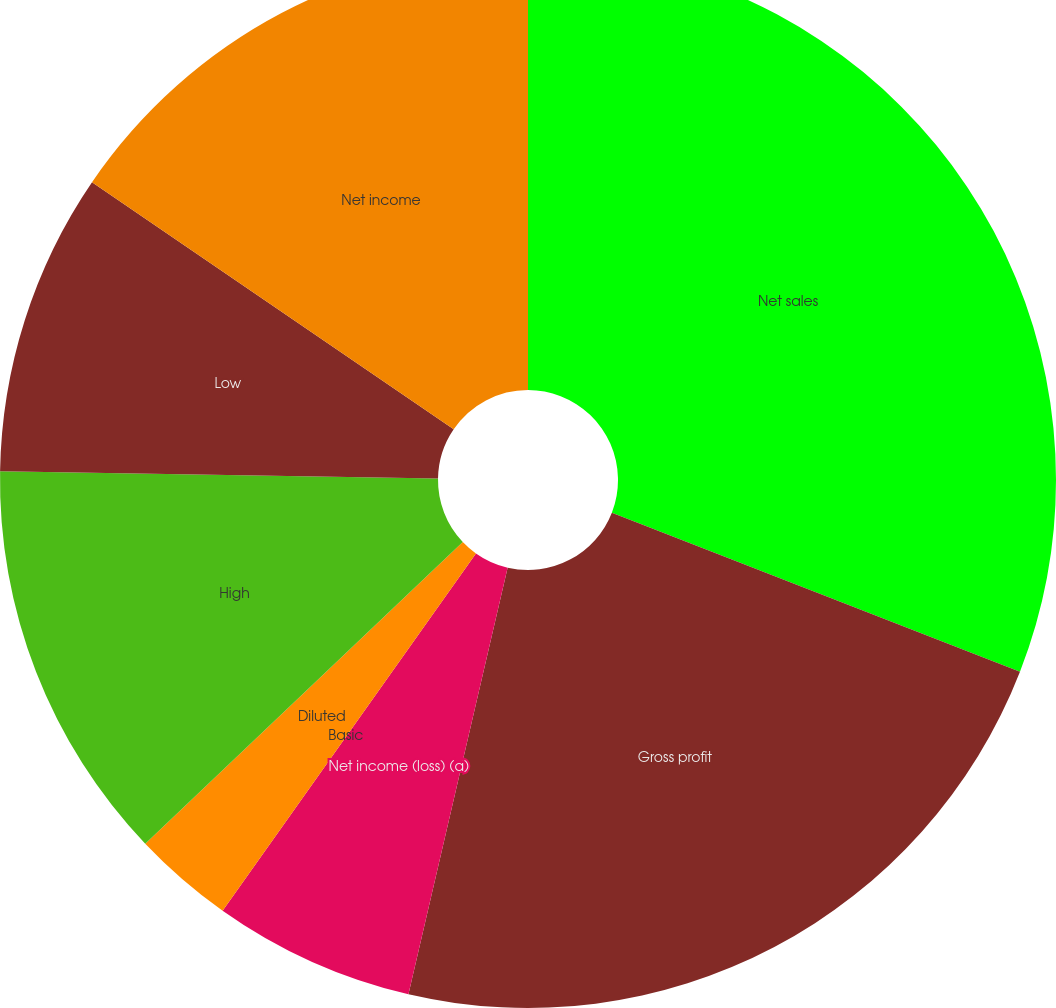<chart> <loc_0><loc_0><loc_500><loc_500><pie_chart><fcel>Net sales<fcel>Gross profit<fcel>Net income (loss) (a)<fcel>Basic<fcel>Diluted<fcel>High<fcel>Low<fcel>Net income<nl><fcel>30.91%<fcel>22.72%<fcel>6.18%<fcel>0.0%<fcel>3.09%<fcel>12.36%<fcel>9.27%<fcel>15.46%<nl></chart> 